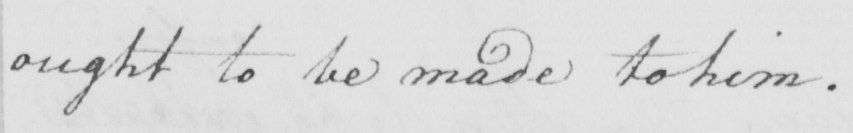What is written in this line of handwriting? ought to be made to her . 